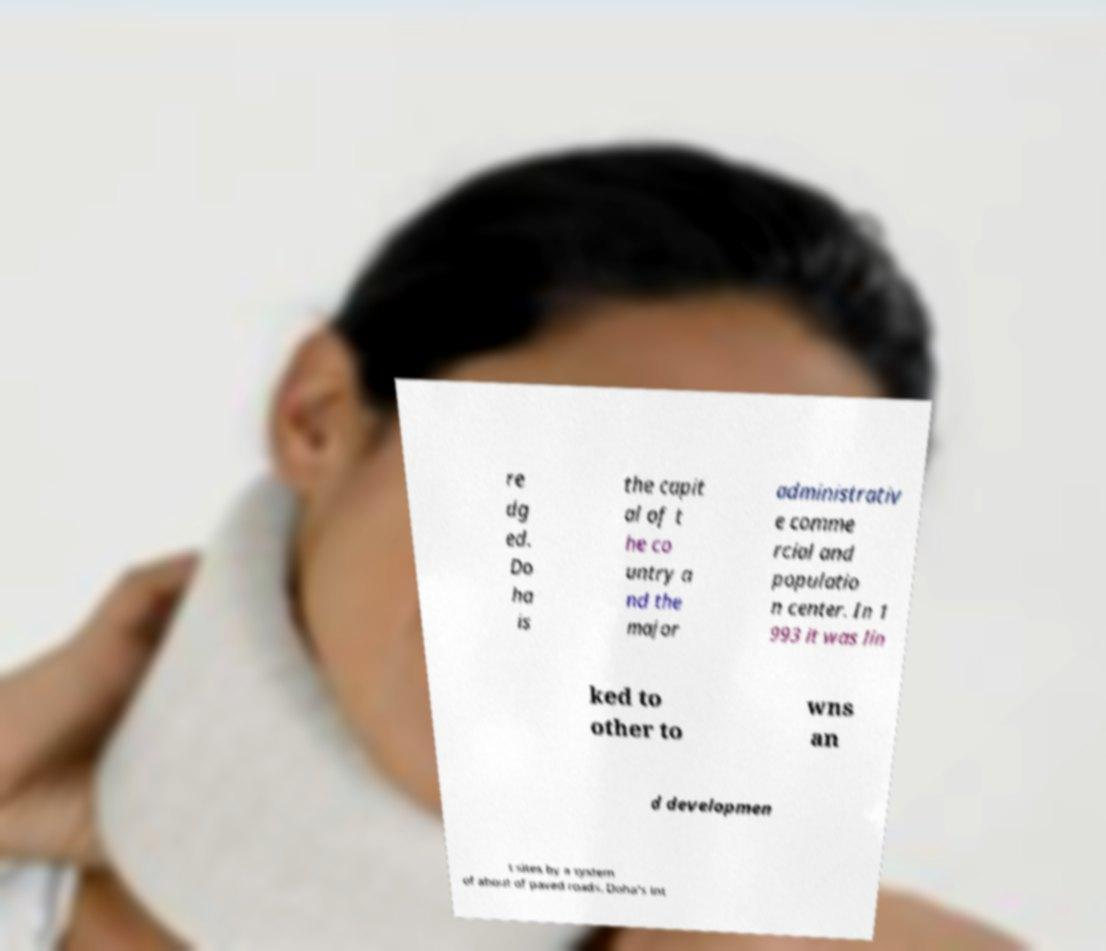What messages or text are displayed in this image? I need them in a readable, typed format. re dg ed. Do ha is the capit al of t he co untry a nd the major administrativ e comme rcial and populatio n center. In 1 993 it was lin ked to other to wns an d developmen t sites by a system of about of paved roads. Doha's int 